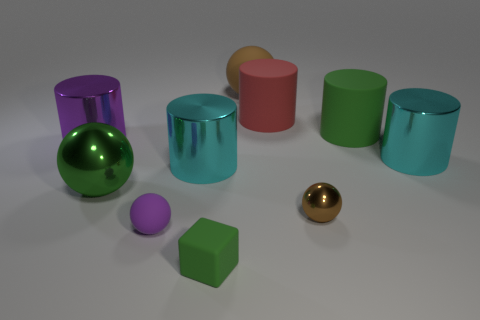Subtract all shiny cylinders. How many cylinders are left? 2 Subtract all brown spheres. How many spheres are left? 2 Subtract all balls. How many objects are left? 6 Subtract 4 cylinders. How many cylinders are left? 1 Add 7 big red rubber things. How many big red rubber things exist? 8 Subtract 0 red cubes. How many objects are left? 10 Subtract all purple cylinders. Subtract all gray cubes. How many cylinders are left? 4 Subtract all cyan cylinders. How many yellow spheres are left? 0 Subtract all green metal spheres. Subtract all shiny balls. How many objects are left? 7 Add 5 rubber cylinders. How many rubber cylinders are left? 7 